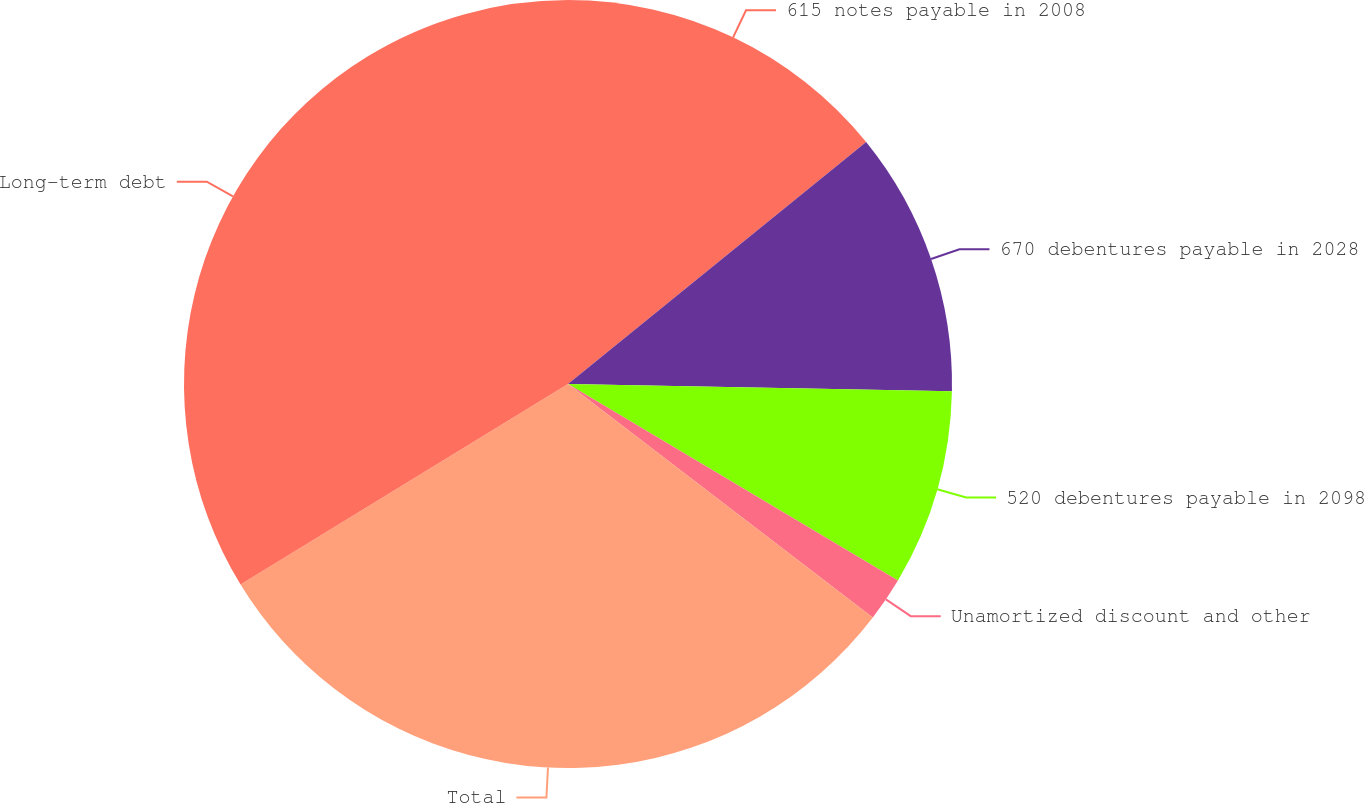<chart> <loc_0><loc_0><loc_500><loc_500><pie_chart><fcel>615 notes payable in 2008<fcel>670 debentures payable in 2028<fcel>520 debentures payable in 2098<fcel>Unamortized discount and other<fcel>Total<fcel>Long-term debt<nl><fcel>14.15%<fcel>11.15%<fcel>8.25%<fcel>1.86%<fcel>30.85%<fcel>33.75%<nl></chart> 